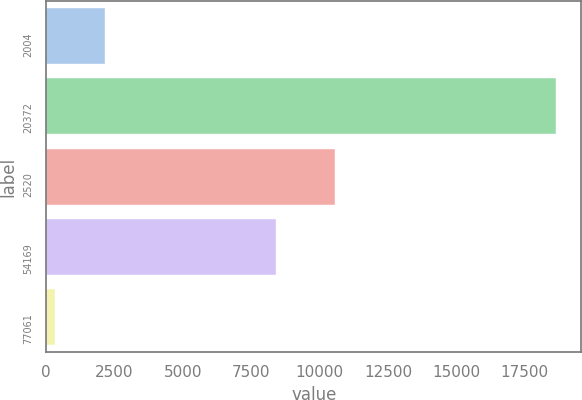Convert chart. <chart><loc_0><loc_0><loc_500><loc_500><bar_chart><fcel>2004<fcel>20372<fcel>2520<fcel>54169<fcel>77061<nl><fcel>2144.2<fcel>18643<fcel>10554<fcel>8400<fcel>311<nl></chart> 